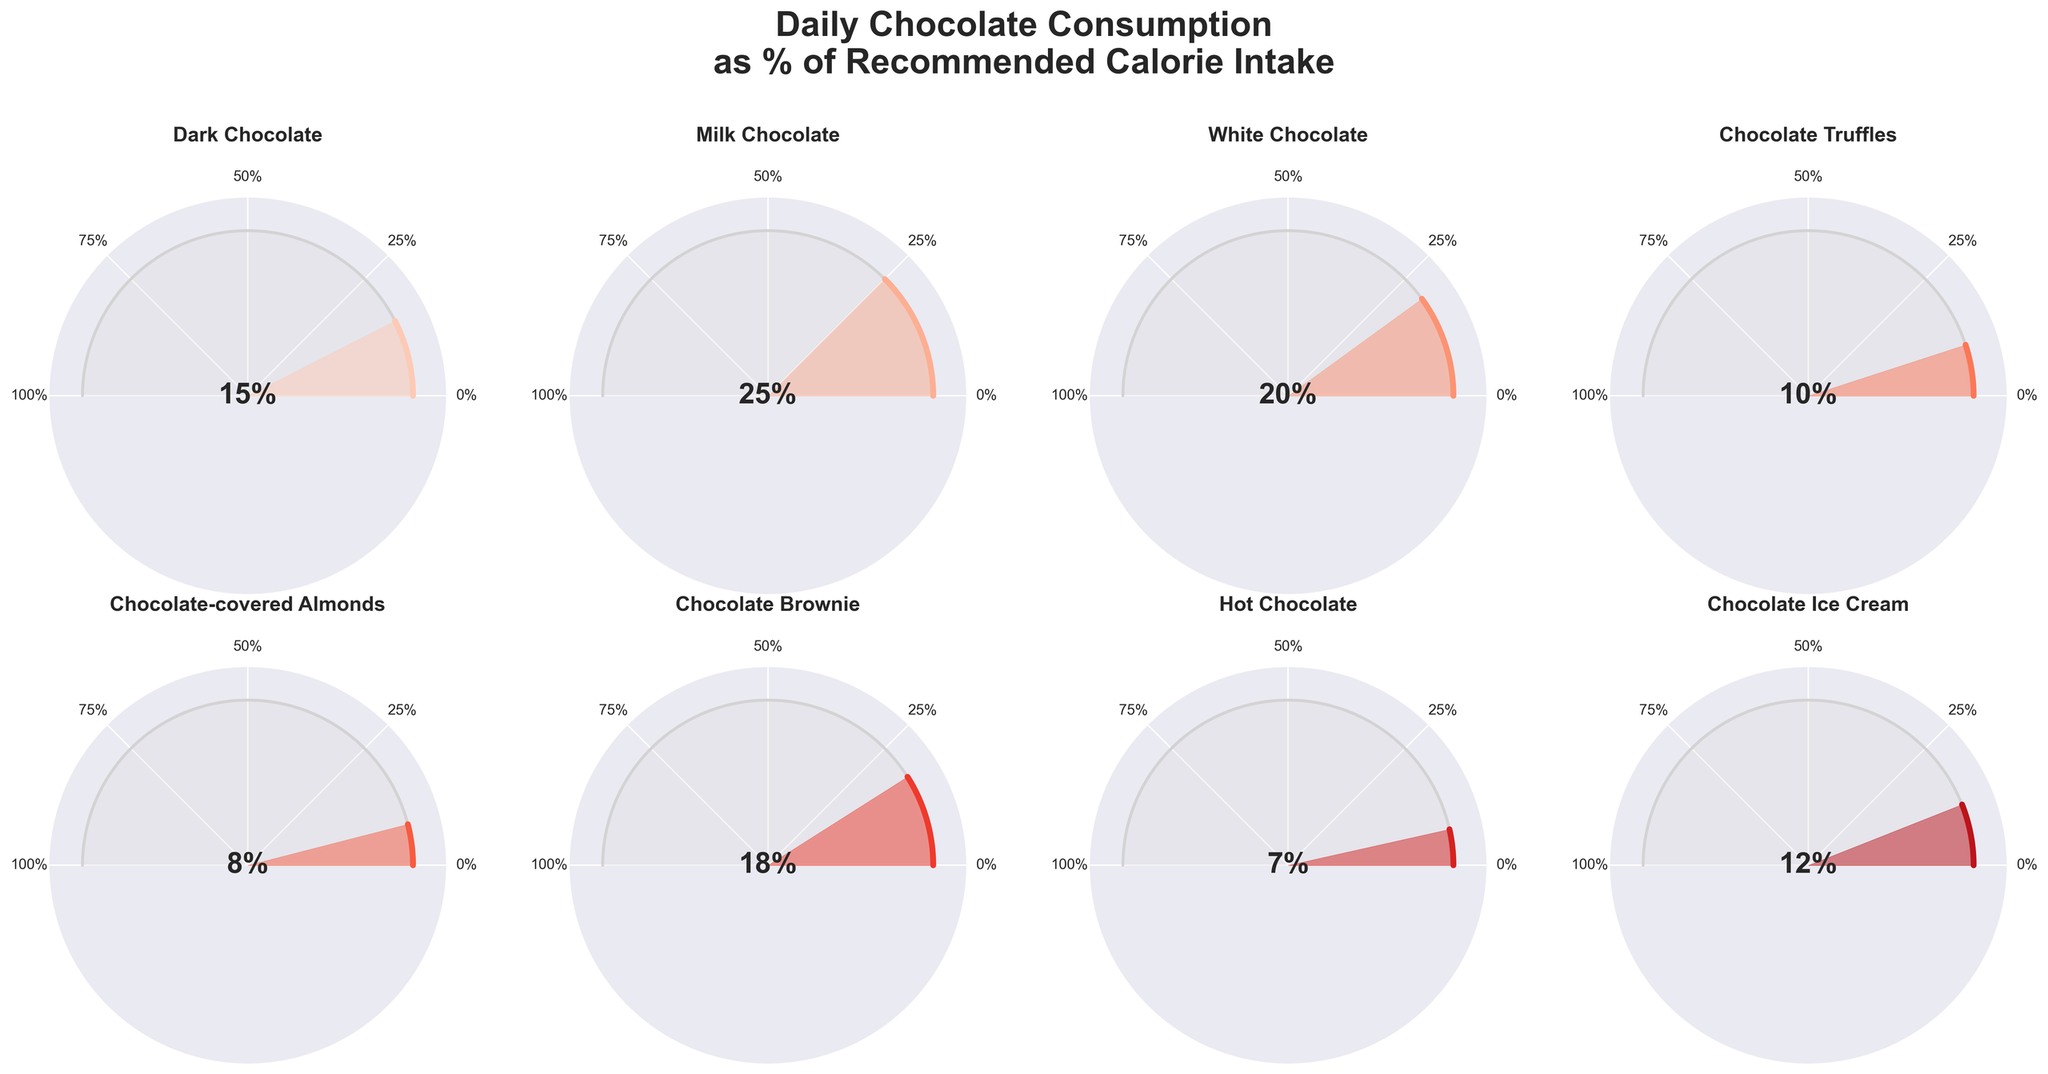What's the percentage of daily calories coming from Milk Chocolate? The gauge chart for Milk Chocolate shows that the needle is pointing to 25%, and the percentage text also confirms this value.
Answer: 25% How many types of chocolates contribute more than 15% of the daily recommended calorie intake? The chocolates that contribute more than 15% are Milk Chocolate (25%), White Chocolate (20%), and Chocolate Brownie (18%). There are three such chocolates.
Answer: 3 Which type of chocolate contributes the least to the daily calorie intake? The gauge chart for Hot Chocolate shows a value of 7%, which is the smallest value on the figure.
Answer: Hot Chocolate What’s the total percentage of daily calories consumed from Dark Chocolate and Chocolate Truffles? Dark Chocolate accounts for 15% and Chocolate Truffles for 10%. Summing these, 15% + 10% = 25%.
Answer: 25% Which chocolate type has the closest daily calorie percentage to Chocolate Ice Cream? Chocolate Ice Cream contributes 12%. The closest value to this is Hot Chocolate with 7% or Chocolate-covered Almonds with 8%, but by numerical closeness, Chocolate-covered Almonds at 8% is nearer.
Answer: Chocolate-covered Almonds What's the difference between the highest and lowest percentage chocolate types? The highest percentage is Milk Chocolate at 25%, and the lowest is Hot Chocolate at 7%. The difference is 25% - 7% = 18%.
Answer: 18% What is the average percentage of daily calories from all listed chocolate types? Sum the percentages of all chocolates: 15 + 25 + 20 + 10 + 8 + 18 + 7 + 12 = 115%. With 8 types, the average is 115/8 = 14.375%.
Answer: 14.375% Which chocolate type has a higher daily calorie percentage: White Chocolate or Chocolate Brownie? The gauge chart for White Chocolate shows 20%, while Chocolate Brownie shows 18%. 20% is higher than 18%.
Answer: White Chocolate Which type of chocolate has a daily calorie percentage twice as high as Dark Chocolate? Dark Chocolate is at 15%, so we are looking for 2 * 15% = 30%. None in the list has 30%, thus no type fits this criterion exactly.
Answer: None 